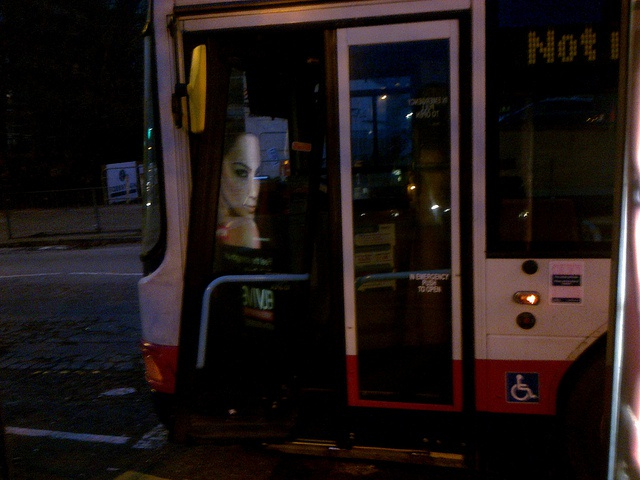Describe the objects in this image and their specific colors. I can see bus in black, brown, and maroon tones in this image. 